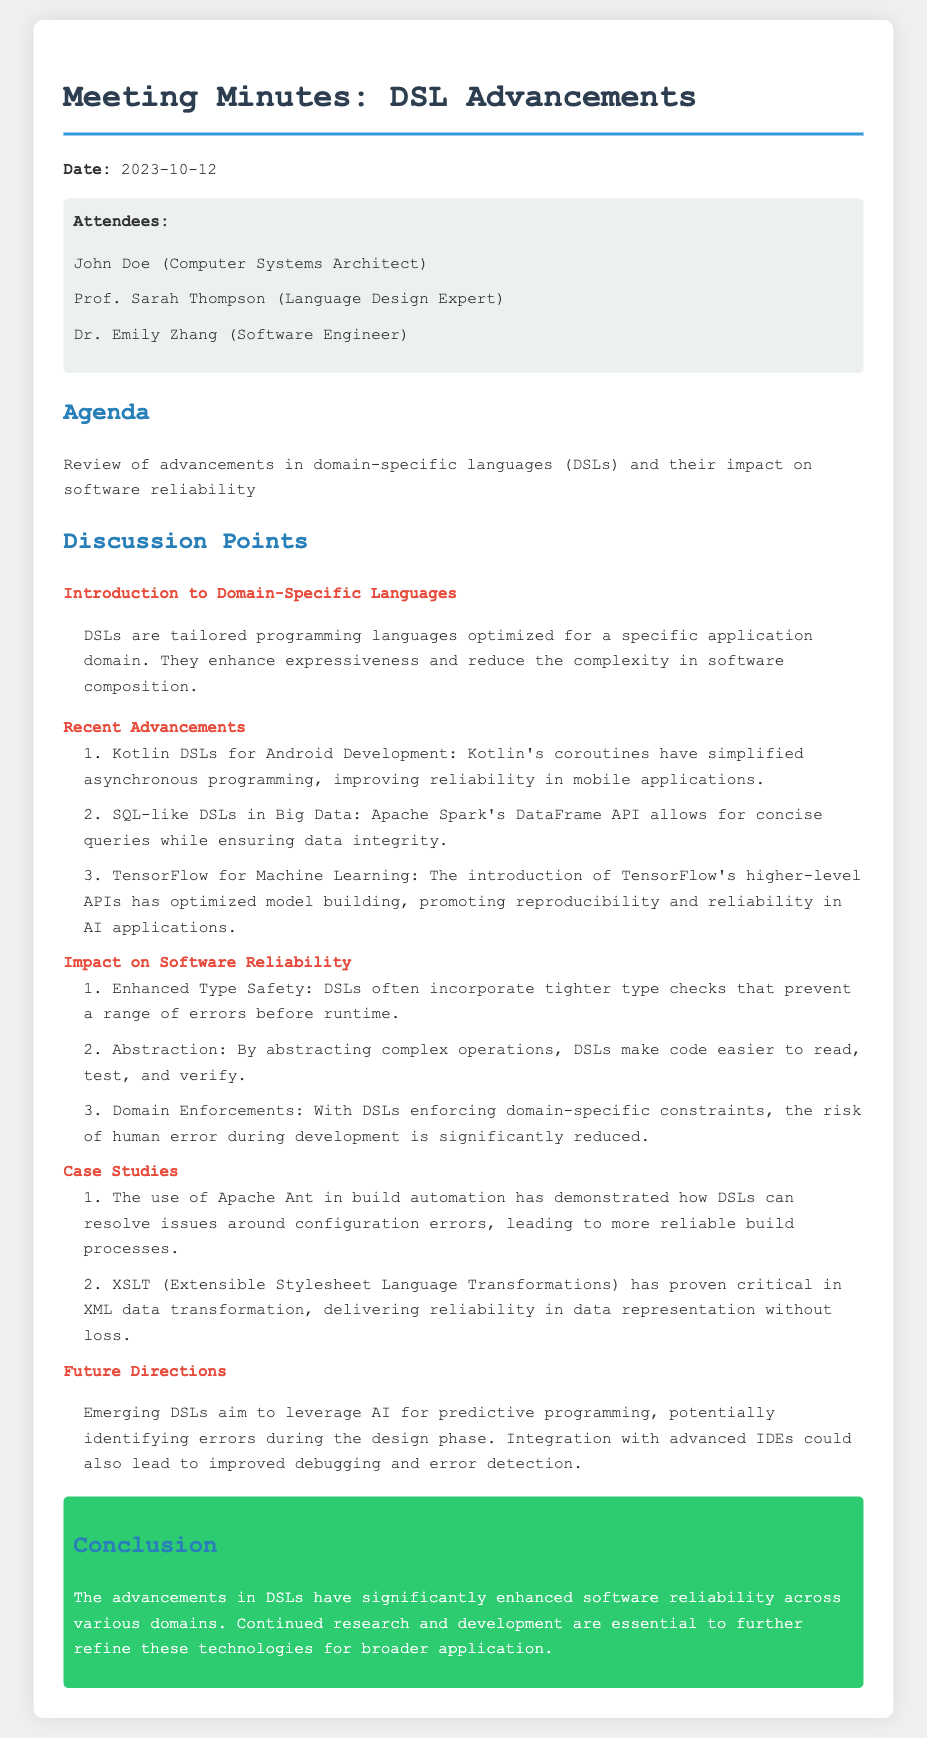what is the date of the meeting? The date of the meeting is explicitly mentioned at the beginning of the document.
Answer: 2023-10-12 who is the language design expert attendee? The document lists attendees in a section, where the language design expert is identified.
Answer: Prof. Sarah Thompson what is one recent advancement in domain-specific languages mentioned? The document includes a list of recent advancements as points of discussion.
Answer: Kotlin DSLs for Android Development how do DSLs enhance software reliability? The document explains the impact of DSLs on software reliability with specific points.
Answer: Enhanced Type Safety what is a case study mentioned in the meeting? The document contains a subsection about case studies highlighting real-world applications of DSLs.
Answer: Apache Ant in build automation what is a future direction for DSLs? The document includes a section discussing potential future developments in the field of DSLs.
Answer: AI for predictive programming 